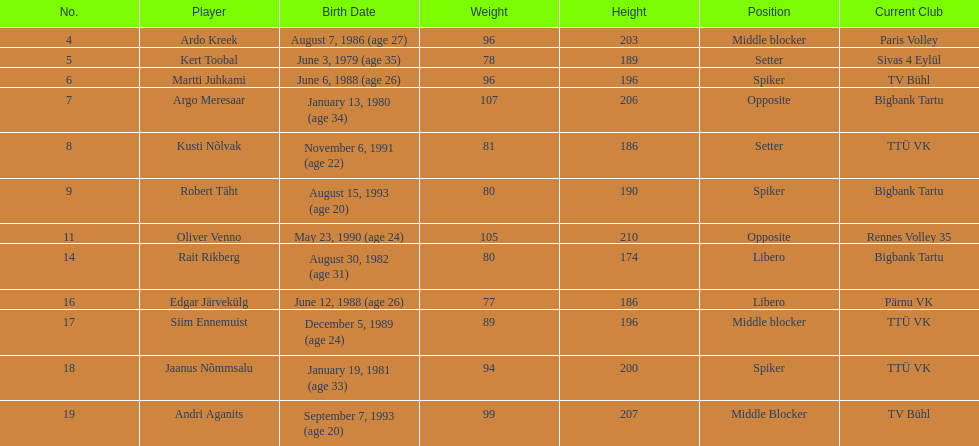What is the height difference between oliver venno and rait rikberg? 36. 